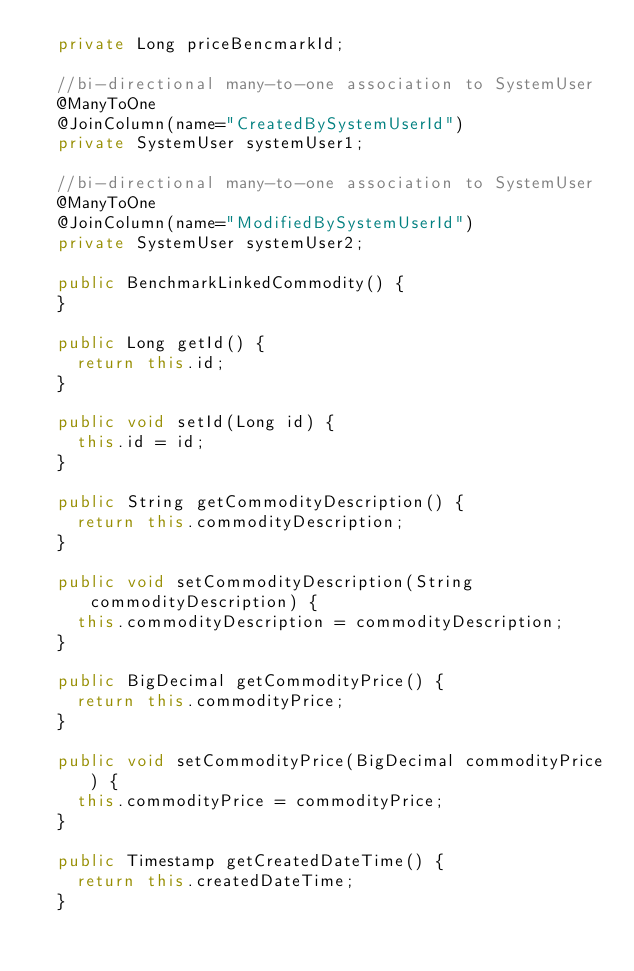Convert code to text. <code><loc_0><loc_0><loc_500><loc_500><_Java_>	private Long priceBencmarkId;

	//bi-directional many-to-one association to SystemUser
	@ManyToOne
	@JoinColumn(name="CreatedBySystemUserId")
	private SystemUser systemUser1;

	//bi-directional many-to-one association to SystemUser
	@ManyToOne
	@JoinColumn(name="ModifiedBySystemUserId")
	private SystemUser systemUser2;

	public BenchmarkLinkedCommodity() {
	}

	public Long getId() {
		return this.id;
	}

	public void setId(Long id) {
		this.id = id;
	}

	public String getCommodityDescription() {
		return this.commodityDescription;
	}

	public void setCommodityDescription(String commodityDescription) {
		this.commodityDescription = commodityDescription;
	}

	public BigDecimal getCommodityPrice() {
		return this.commodityPrice;
	}

	public void setCommodityPrice(BigDecimal commodityPrice) {
		this.commodityPrice = commodityPrice;
	}

	public Timestamp getCreatedDateTime() {
		return this.createdDateTime;
	}
</code> 